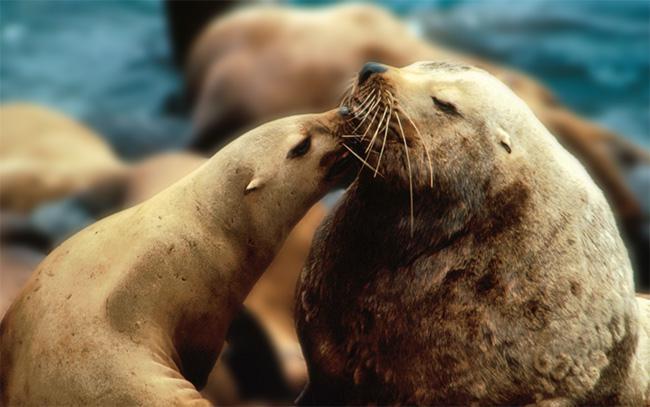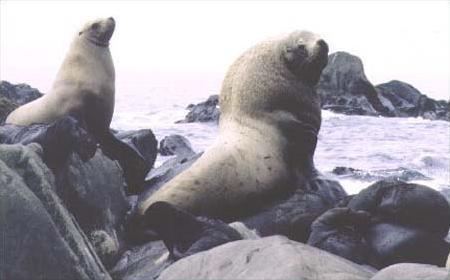The first image is the image on the left, the second image is the image on the right. For the images shown, is this caption "One seal is in the water facing left in one image." true? Answer yes or no. No. The first image is the image on the left, the second image is the image on the right. Analyze the images presented: Is the assertion "In at least one image there is a lone seal sitting in shallow water" valid? Answer yes or no. No. 